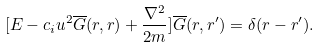<formula> <loc_0><loc_0><loc_500><loc_500>[ E - { c _ { i } u ^ { 2 } } \overline { G } ( { r } , { r } ) + \frac { \nabla ^ { 2 } } { 2 m } ] { \overline { G } ( { r } , { r ^ { \prime } } ) } = \delta ( { r } - { r ^ { \prime } } ) .</formula> 